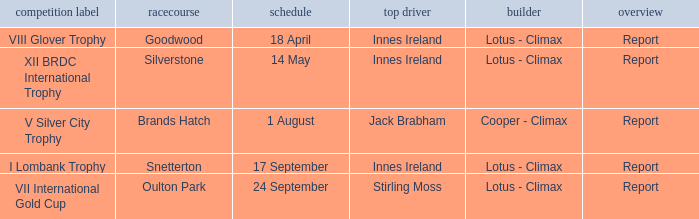What circuit did Innes Ireland win at for the I lombank trophy? Snetterton. 